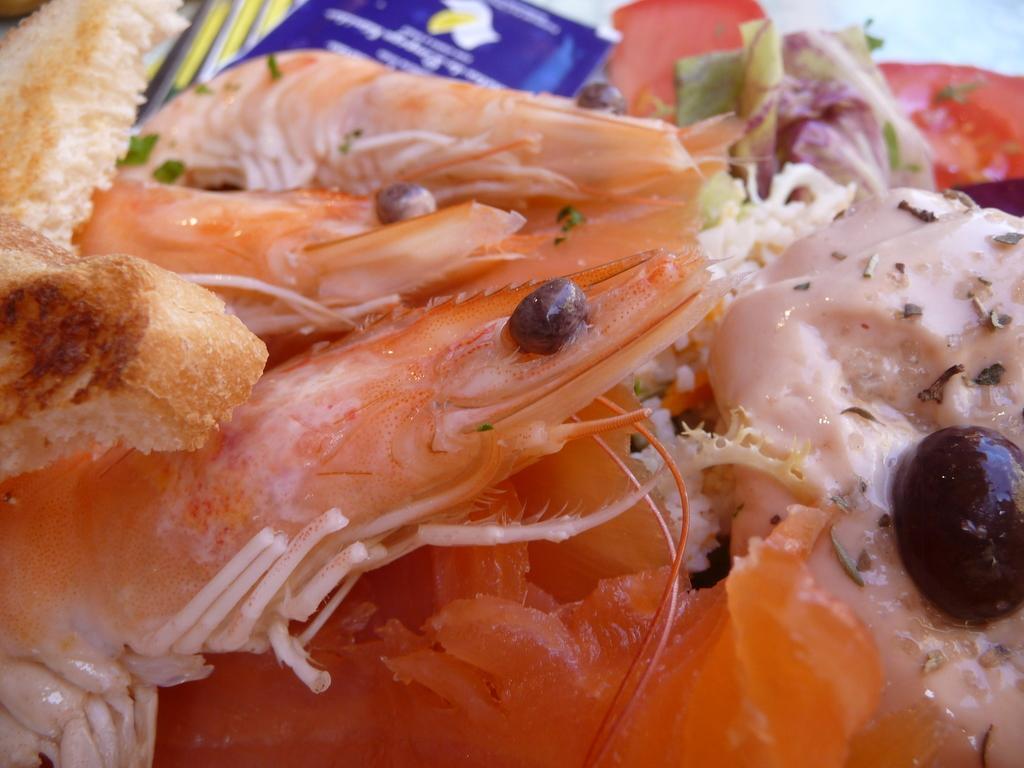Can you describe this image briefly? There are prawns and other items in the foreground area of the image. 